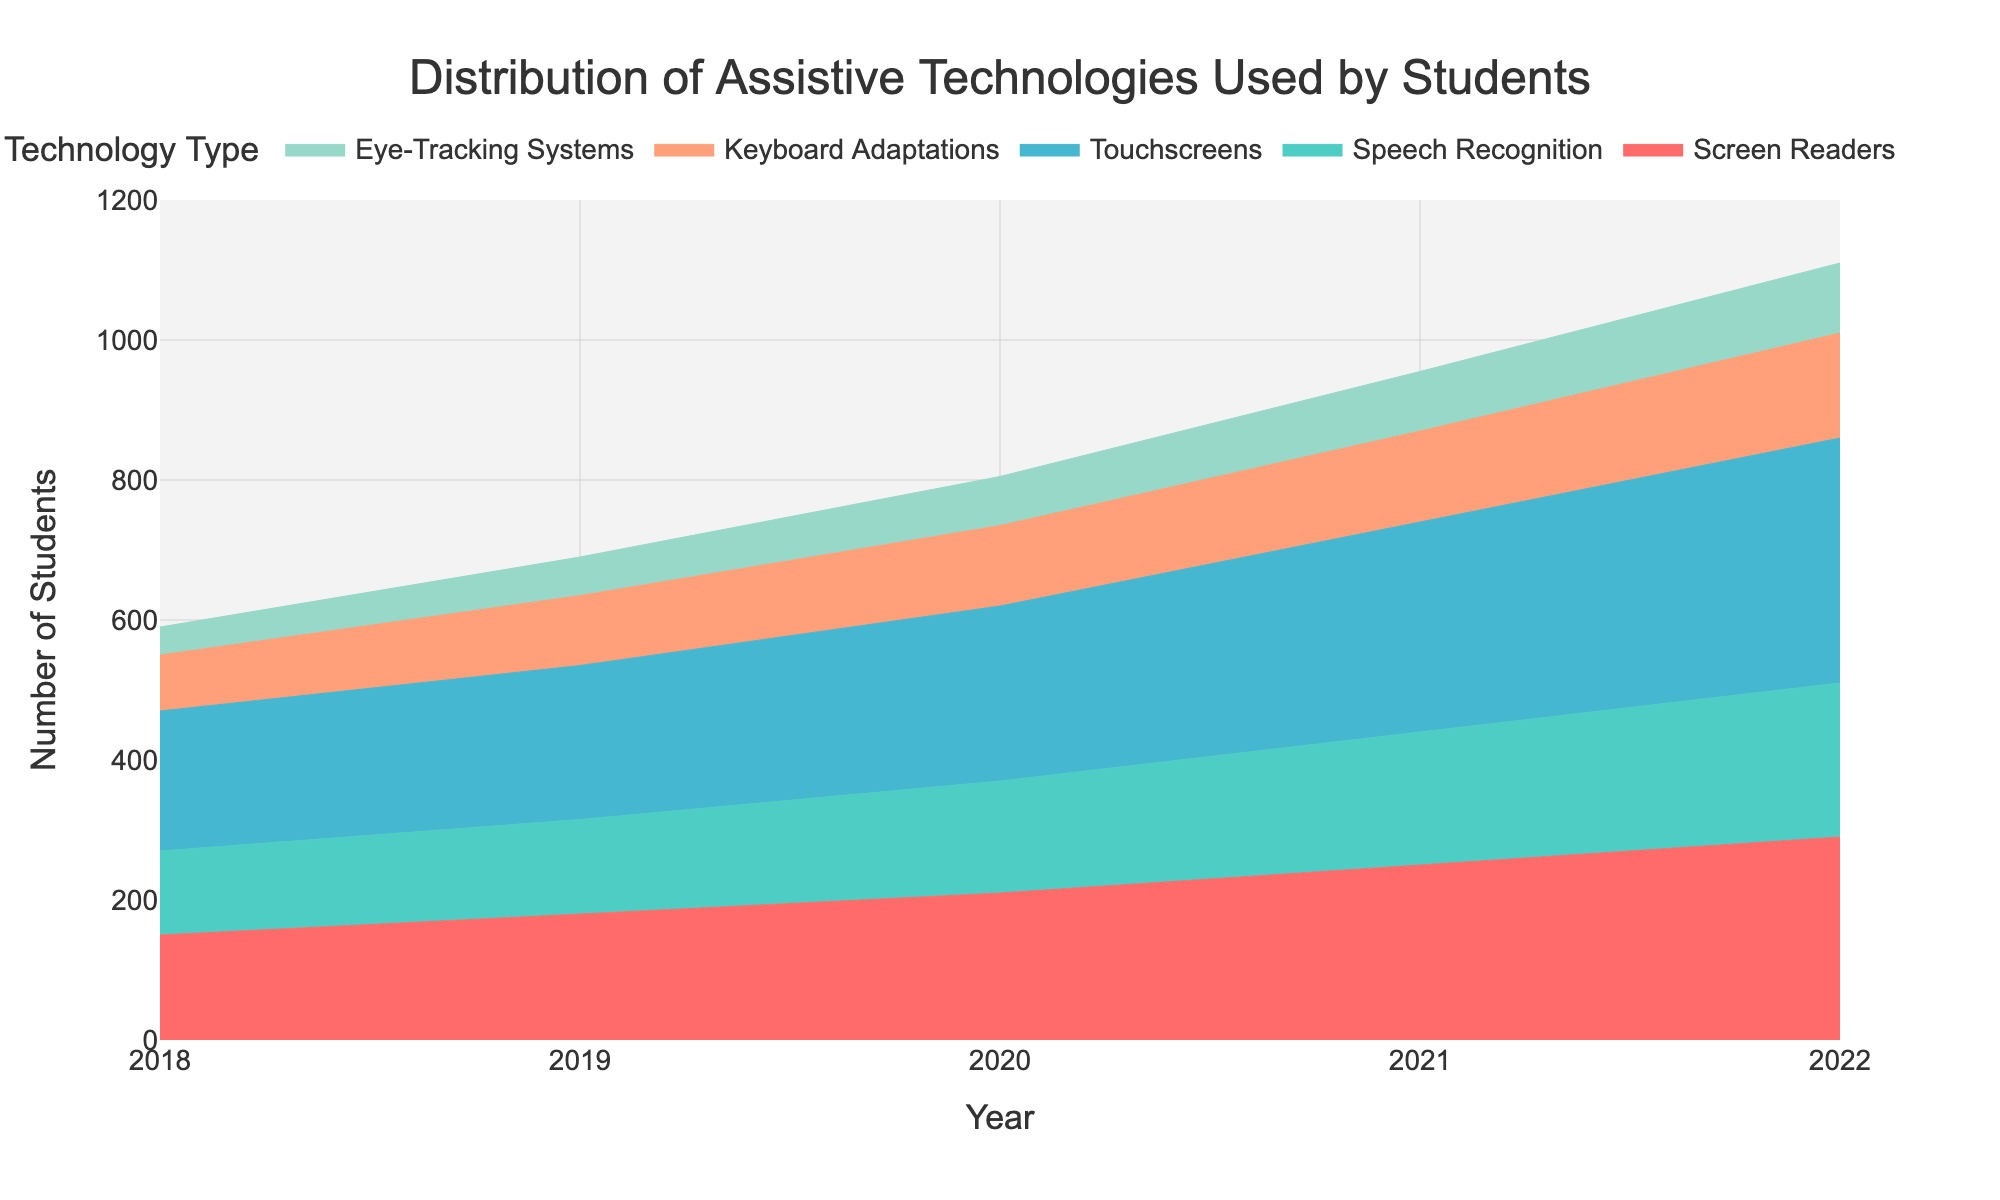What is the title of the area chart? The title is usually found at the top of the figure and summarizes the main topic of the chart. In this area chart, the title is placed above the plot in a prominent position.
Answer: Distribution of Assistive Technologies Used by Students How many types of assistive technologies are represented in the area chart? The number of types can be counted by looking at the legend or by counting the different colors representing each type on the chart.
Answer: 5 Which assistive technology had the highest usage in 2022? To find this, look for the area segment extending the highest on the y-axis for the year 2022.
Answer: Touchscreens What is the range of the y-axis in the chart? The y-axis range can be determined by looking at the minimum and maximum values labeled along the y-axis.
Answer: 0 to 1200 What year did Eye-Tracking Systems surpass 50 users? Check the data points represented by the area for Eye-Tracking Systems each year until the y-axis value exceeds 50.
Answer: 2019 By how much did the number of students using Keyboard Adaptations increase from 2018 to 2022? Subtract the y-axis value of Keyboard Adaptations in 2018 from the y-axis value in 2022. 150 (2022) - 80 (2018) = 70
Answer: 70 Which assistive technology experienced the most significant increase in usage over the given years? Calculate the difference between the 2022 and 2018 values for each technology and compare them. Touchscreens: 350 - 200 = 150, Screen Readers: 290 - 150 = 140, etc.
Answer: Touchscreens Was the usage of Speech Recognition higher in 2019 or 2021? Look at the y-axis values for Speech Recognition for the years 2019 and 2021 and compare them.
Answer: 2021 What can you infer about the trend of total assistive technology usage over the years? Combine the visible trends of all technologies to see if overall usage is increasing or decreasing. If all areas are expanding, total usage is increasing.
Answer: Increasing How many students used Eye-Tracking Systems in 2020 compared to Speech Recognition in the same year? Find the values for both Eye-Tracking Systems and Speech Recognition in 2020 and compare them directly. Eye-Tracking Systems: 70, Speech Recognition: 160.
Answer: Speech Recognition had 90 more users 